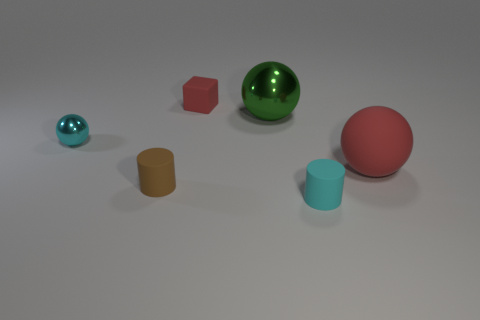What might be the purpose of arranging these objects like this? This arrangement may serve multiple purposes. It could be a part of a visual composition study, focusing on color contrast, shape recognition, and spatial distribution. It could also be for an educational demonstration to teach about geometry, comparing and contrasting various geometric shapes and their properties. 